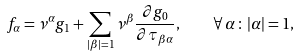<formula> <loc_0><loc_0><loc_500><loc_500>f _ { \alpha } = \nu ^ { \alpha } g _ { 1 } + \sum _ { | \beta | = 1 } \nu ^ { \beta } \frac { \partial g _ { 0 } } { \partial \tau _ { \beta \alpha } } , \quad \forall \, \alpha \, \colon \, | \alpha | = 1 ,</formula> 